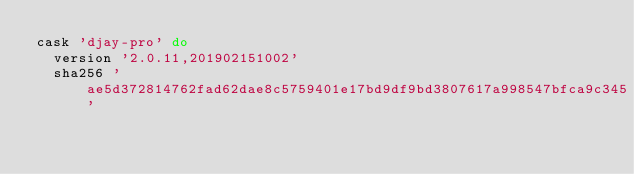<code> <loc_0><loc_0><loc_500><loc_500><_Ruby_>cask 'djay-pro' do
  version '2.0.11,201902151002'
  sha256 'ae5d372814762fad62dae8c5759401e17bd9df9bd3807617a998547bfca9c345'
</code> 